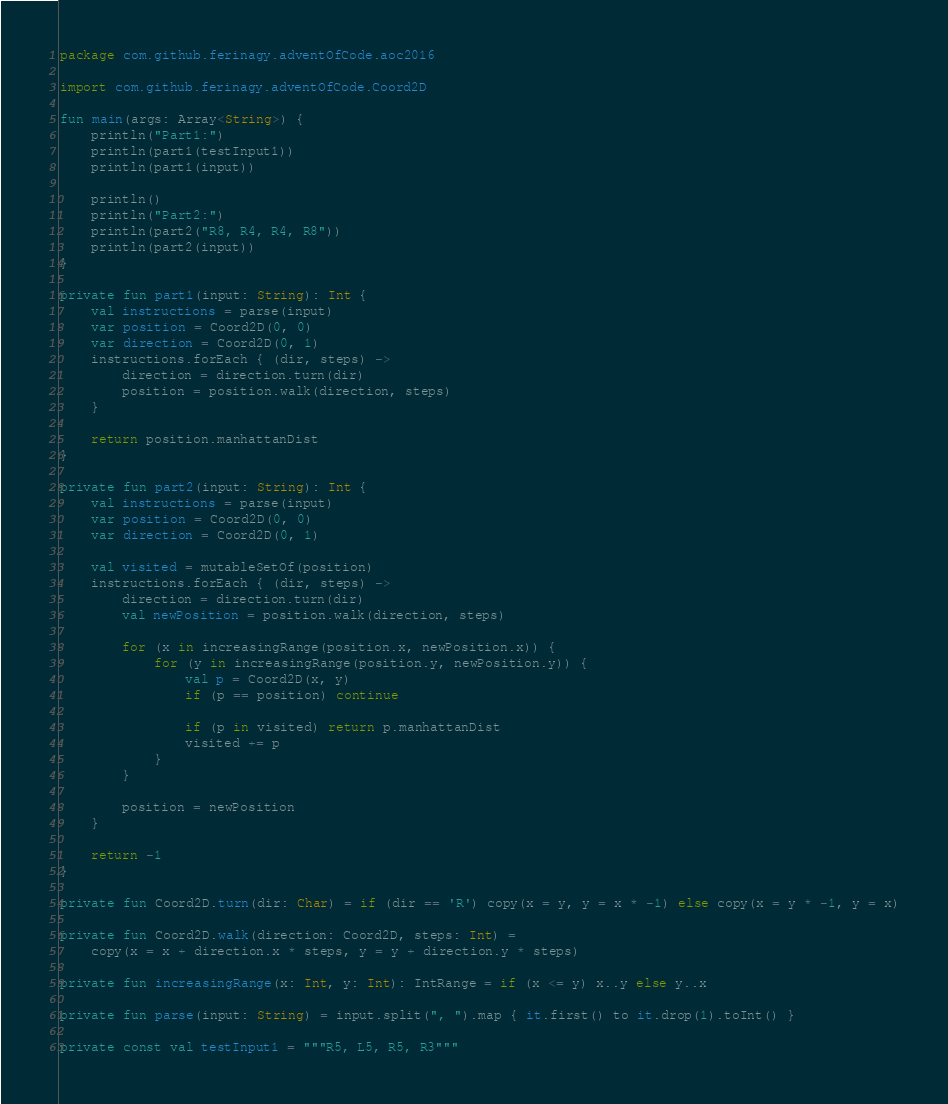Convert code to text. <code><loc_0><loc_0><loc_500><loc_500><_Kotlin_>package com.github.ferinagy.adventOfCode.aoc2016

import com.github.ferinagy.adventOfCode.Coord2D

fun main(args: Array<String>) {
    println("Part1:")
    println(part1(testInput1))
    println(part1(input))

    println()
    println("Part2:")
    println(part2("R8, R4, R4, R8"))
    println(part2(input))
}

private fun part1(input: String): Int {
    val instructions = parse(input)
    var position = Coord2D(0, 0)
    var direction = Coord2D(0, 1)
    instructions.forEach { (dir, steps) ->
        direction = direction.turn(dir)
        position = position.walk(direction, steps)
    }

    return position.manhattanDist
}

private fun part2(input: String): Int {
    val instructions = parse(input)
    var position = Coord2D(0, 0)
    var direction = Coord2D(0, 1)

    val visited = mutableSetOf(position)
    instructions.forEach { (dir, steps) ->
        direction = direction.turn(dir)
        val newPosition = position.walk(direction, steps)

        for (x in increasingRange(position.x, newPosition.x)) {
            for (y in increasingRange(position.y, newPosition.y)) {
                val p = Coord2D(x, y)
                if (p == position) continue

                if (p in visited) return p.manhattanDist
                visited += p
            }
        }

        position = newPosition
    }

    return -1
}

private fun Coord2D.turn(dir: Char) = if (dir == 'R') copy(x = y, y = x * -1) else copy(x = y * -1, y = x)

private fun Coord2D.walk(direction: Coord2D, steps: Int) =
    copy(x = x + direction.x * steps, y = y + direction.y * steps)

private fun increasingRange(x: Int, y: Int): IntRange = if (x <= y) x..y else y..x

private fun parse(input: String) = input.split(", ").map { it.first() to it.drop(1).toInt() }

private const val testInput1 = """R5, L5, R5, R3"""
</code> 